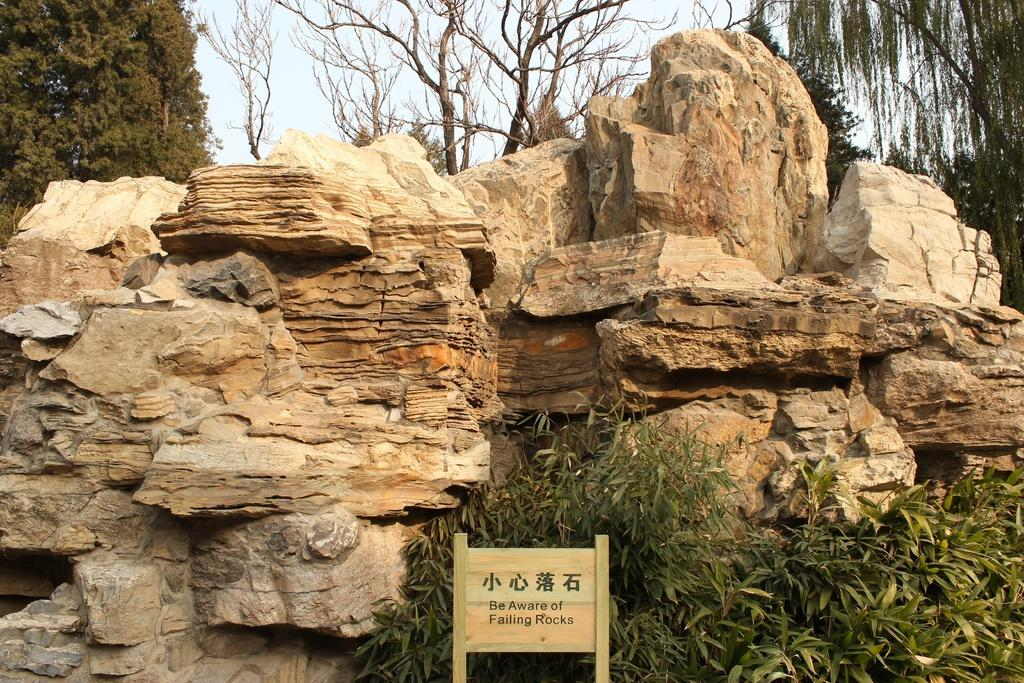What type of natural objects can be seen in the image? There are rocks in the image. What is attached to the rocks in the image? There is a poster in the image. What message does the poster convey? The poster has the text "Be aware of falling rocks." What type of vegetation can be seen in the background of the image? There are trees in the background of the image. What type of reward is being offered to the parent in the image? There is no reward or parent present in the image; it features rocks and a poster with a warning about falling rocks. How much sugar is visible in the image? There is no sugar present in the image. 